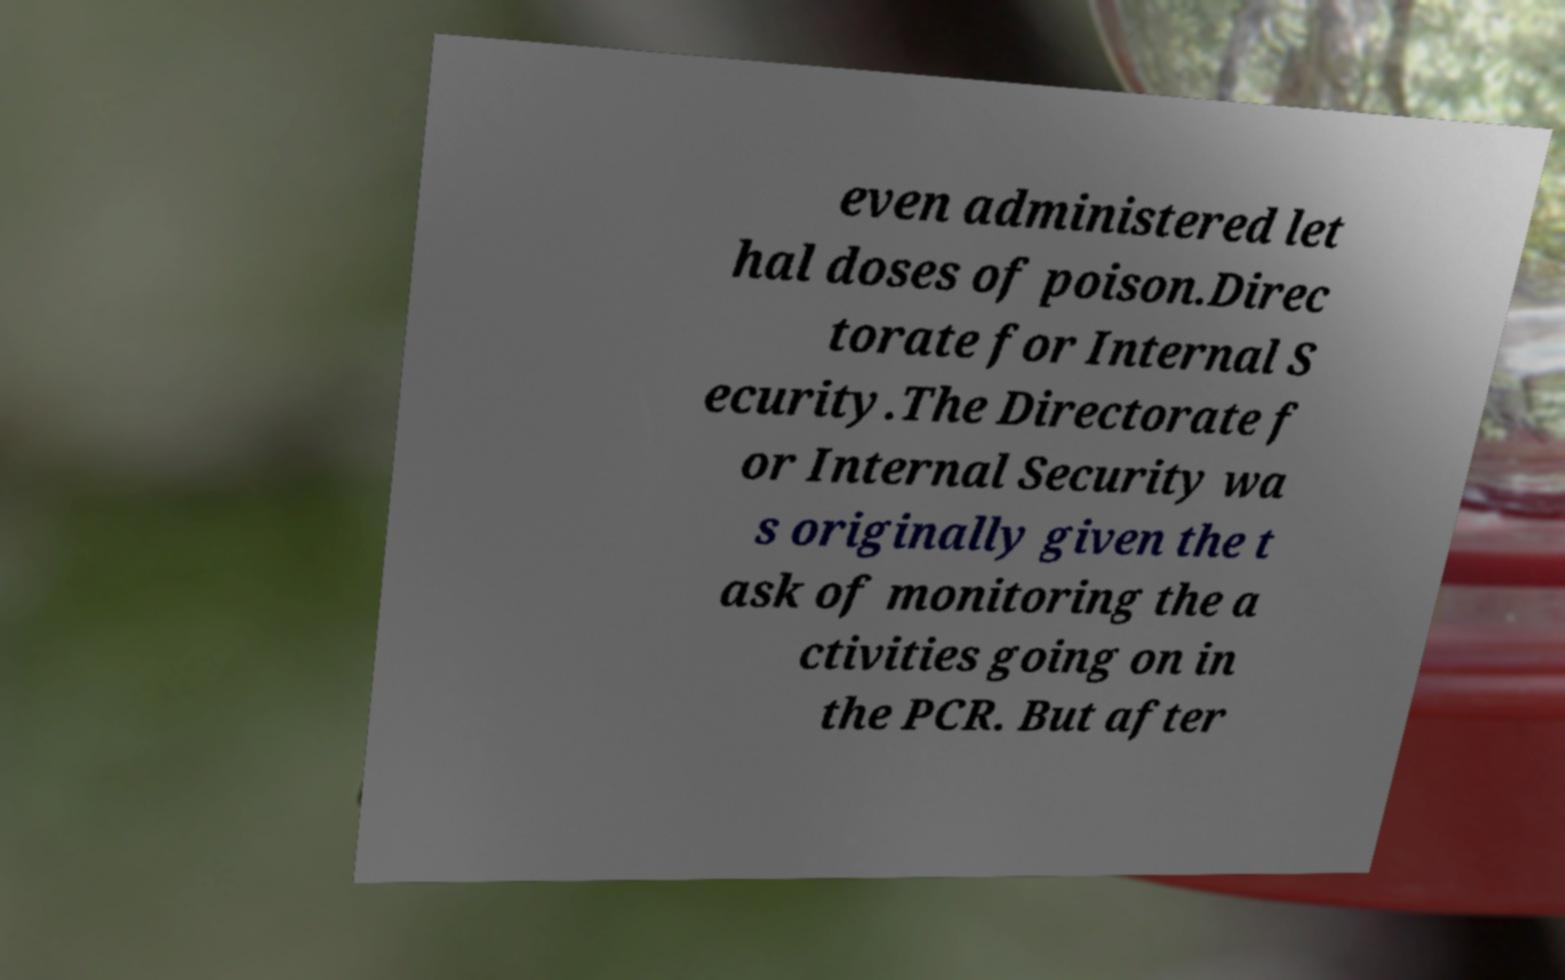There's text embedded in this image that I need extracted. Can you transcribe it verbatim? even administered let hal doses of poison.Direc torate for Internal S ecurity.The Directorate f or Internal Security wa s originally given the t ask of monitoring the a ctivities going on in the PCR. But after 